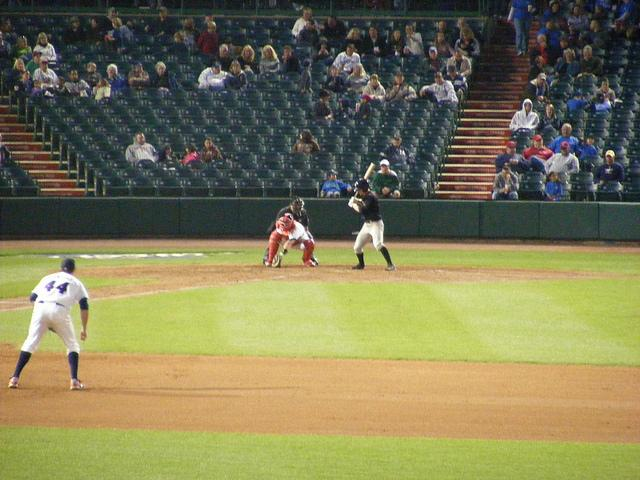How does the temperature likely feel?

Choices:
A) cold
B) hot
C) warm
D) cool cool 